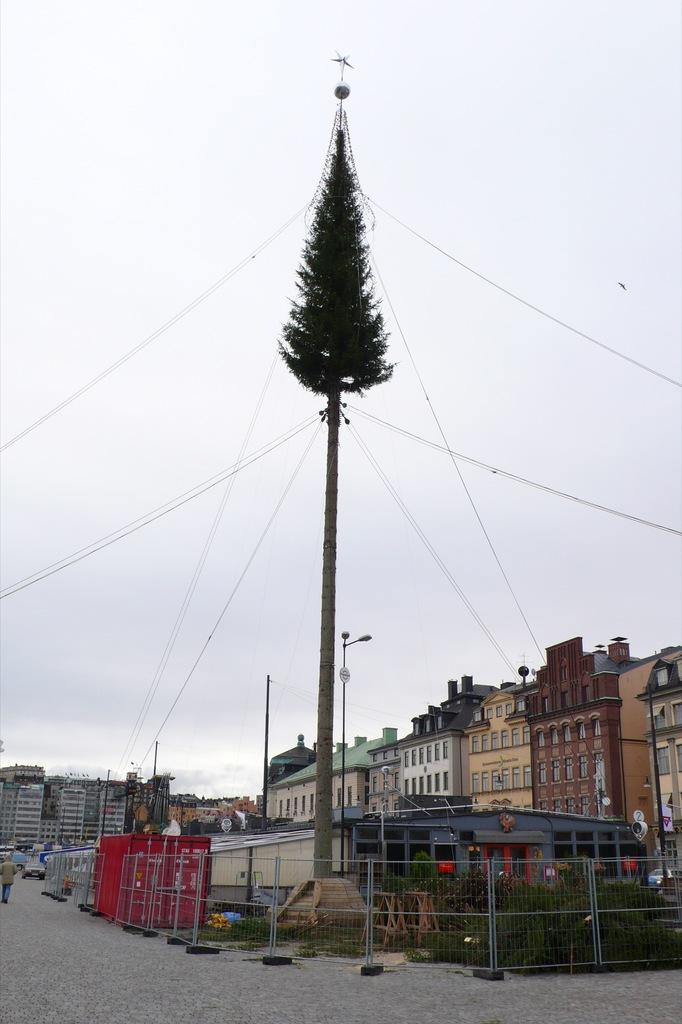What type of vegetation is present in the image? There is a tree and grass in the image. What structures can be seen in the image? There are light-poles and fencing in the image. What can be seen in the background of the image? There are buildings, windows, and the sky visible in the background. What are the people in the image doing? People are walking on the road in the image. What is the color of the sky in the image? The sky is a combination of white and blue colors in the image. What is the purpose of the finger in the image? There is no finger present in the image. How does the sun affect the image? The image does not show the sun, so its effect cannot be determined. 